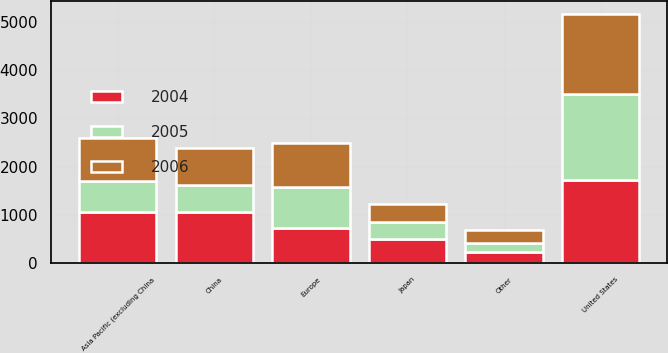Convert chart to OTSL. <chart><loc_0><loc_0><loc_500><loc_500><stacked_bar_chart><ecel><fcel>United States<fcel>Asia Pacific (excluding China<fcel>China<fcel>Europe<fcel>Japan<fcel>Other<nl><fcel>2004<fcel>1721<fcel>1068<fcel>1049<fcel>719<fcel>494<fcel>221<nl><fcel>2006<fcel>1657<fcel>900<fcel>775<fcel>906<fcel>380<fcel>262<nl><fcel>2005<fcel>1789<fcel>633<fcel>560<fcel>864<fcel>355<fcel>203<nl></chart> 